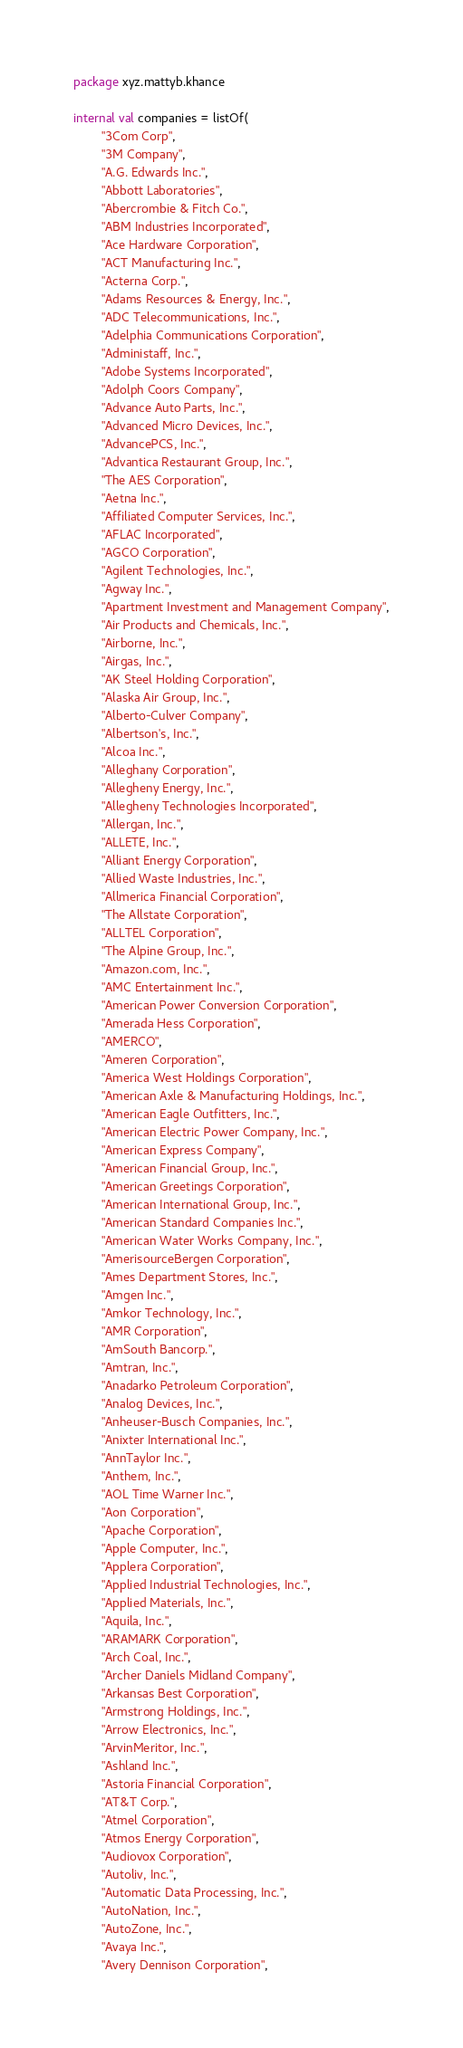Convert code to text. <code><loc_0><loc_0><loc_500><loc_500><_Kotlin_>package xyz.mattyb.khance

internal val companies = listOf(
        "3Com Corp",
        "3M Company",
        "A.G. Edwards Inc.",
        "Abbott Laboratories",
        "Abercrombie & Fitch Co.",
        "ABM Industries Incorporated",
        "Ace Hardware Corporation",
        "ACT Manufacturing Inc.",
        "Acterna Corp.",
        "Adams Resources & Energy, Inc.",
        "ADC Telecommunications, Inc.",
        "Adelphia Communications Corporation",
        "Administaff, Inc.",
        "Adobe Systems Incorporated",
        "Adolph Coors Company",
        "Advance Auto Parts, Inc.",
        "Advanced Micro Devices, Inc.",
        "AdvancePCS, Inc.",
        "Advantica Restaurant Group, Inc.",
        "The AES Corporation",
        "Aetna Inc.",
        "Affiliated Computer Services, Inc.",
        "AFLAC Incorporated",
        "AGCO Corporation",
        "Agilent Technologies, Inc.",
        "Agway Inc.",
        "Apartment Investment and Management Company",
        "Air Products and Chemicals, Inc.",
        "Airborne, Inc.",
        "Airgas, Inc.",
        "AK Steel Holding Corporation",
        "Alaska Air Group, Inc.",
        "Alberto-Culver Company",
        "Albertson's, Inc.",
        "Alcoa Inc.",
        "Alleghany Corporation",
        "Allegheny Energy, Inc.",
        "Allegheny Technologies Incorporated",
        "Allergan, Inc.",
        "ALLETE, Inc.",
        "Alliant Energy Corporation",
        "Allied Waste Industries, Inc.",
        "Allmerica Financial Corporation",
        "The Allstate Corporation",
        "ALLTEL Corporation",
        "The Alpine Group, Inc.",
        "Amazon.com, Inc.",
        "AMC Entertainment Inc.",
        "American Power Conversion Corporation",
        "Amerada Hess Corporation",
        "AMERCO",
        "Ameren Corporation",
        "America West Holdings Corporation",
        "American Axle & Manufacturing Holdings, Inc.",
        "American Eagle Outfitters, Inc.",
        "American Electric Power Company, Inc.",
        "American Express Company",
        "American Financial Group, Inc.",
        "American Greetings Corporation",
        "American International Group, Inc.",
        "American Standard Companies Inc.",
        "American Water Works Company, Inc.",
        "AmerisourceBergen Corporation",
        "Ames Department Stores, Inc.",
        "Amgen Inc.",
        "Amkor Technology, Inc.",
        "AMR Corporation",
        "AmSouth Bancorp.",
        "Amtran, Inc.",
        "Anadarko Petroleum Corporation",
        "Analog Devices, Inc.",
        "Anheuser-Busch Companies, Inc.",
        "Anixter International Inc.",
        "AnnTaylor Inc.",
        "Anthem, Inc.",
        "AOL Time Warner Inc.",
        "Aon Corporation",
        "Apache Corporation",
        "Apple Computer, Inc.",
        "Applera Corporation",
        "Applied Industrial Technologies, Inc.",
        "Applied Materials, Inc.",
        "Aquila, Inc.",
        "ARAMARK Corporation",
        "Arch Coal, Inc.",
        "Archer Daniels Midland Company",
        "Arkansas Best Corporation",
        "Armstrong Holdings, Inc.",
        "Arrow Electronics, Inc.",
        "ArvinMeritor, Inc.",
        "Ashland Inc.",
        "Astoria Financial Corporation",
        "AT&T Corp.",
        "Atmel Corporation",
        "Atmos Energy Corporation",
        "Audiovox Corporation",
        "Autoliv, Inc.",
        "Automatic Data Processing, Inc.",
        "AutoNation, Inc.",
        "AutoZone, Inc.",
        "Avaya Inc.",
        "Avery Dennison Corporation",</code> 